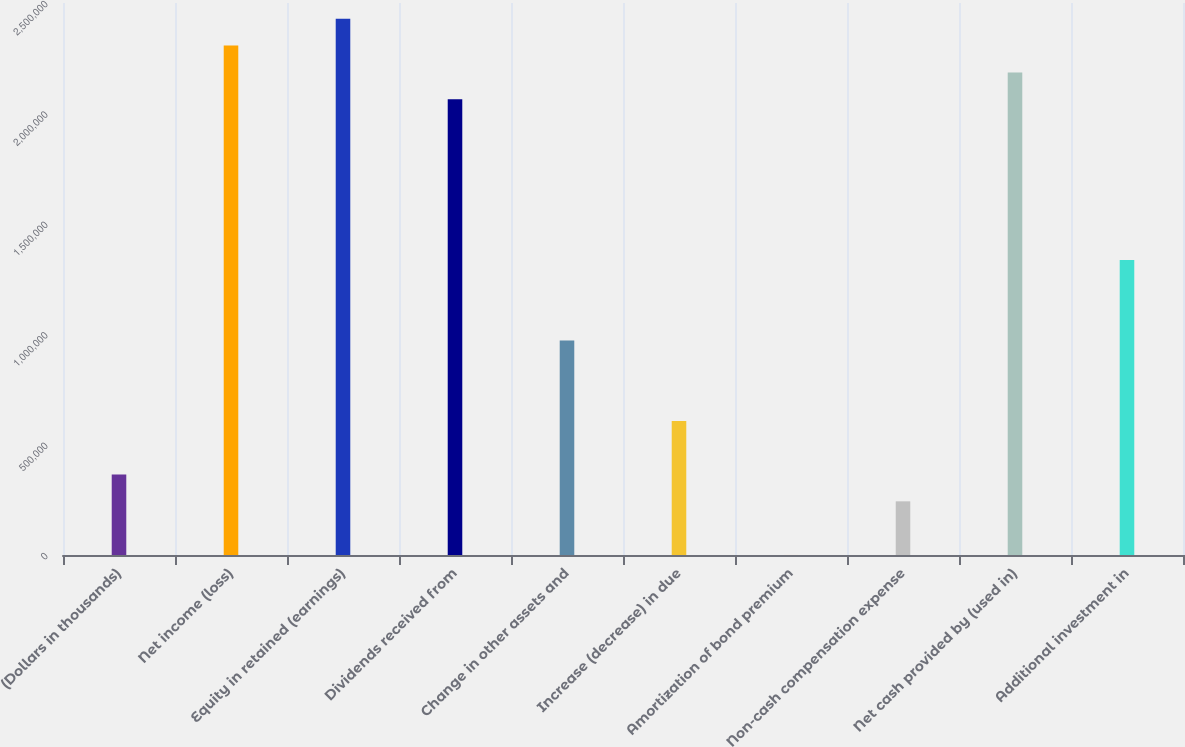Convert chart. <chart><loc_0><loc_0><loc_500><loc_500><bar_chart><fcel>(Dollars in thousands)<fcel>Net income (loss)<fcel>Equity in retained (earnings)<fcel>Dividends received from<fcel>Change in other assets and<fcel>Increase (decrease) in due<fcel>Amortization of bond premium<fcel>Non-cash compensation expense<fcel>Net cash provided by (used in)<fcel>Additional investment in<nl><fcel>364409<fcel>2.30709e+06<fcel>2.42851e+06<fcel>2.06426e+06<fcel>971498<fcel>607245<fcel>156<fcel>242992<fcel>2.18568e+06<fcel>1.33575e+06<nl></chart> 